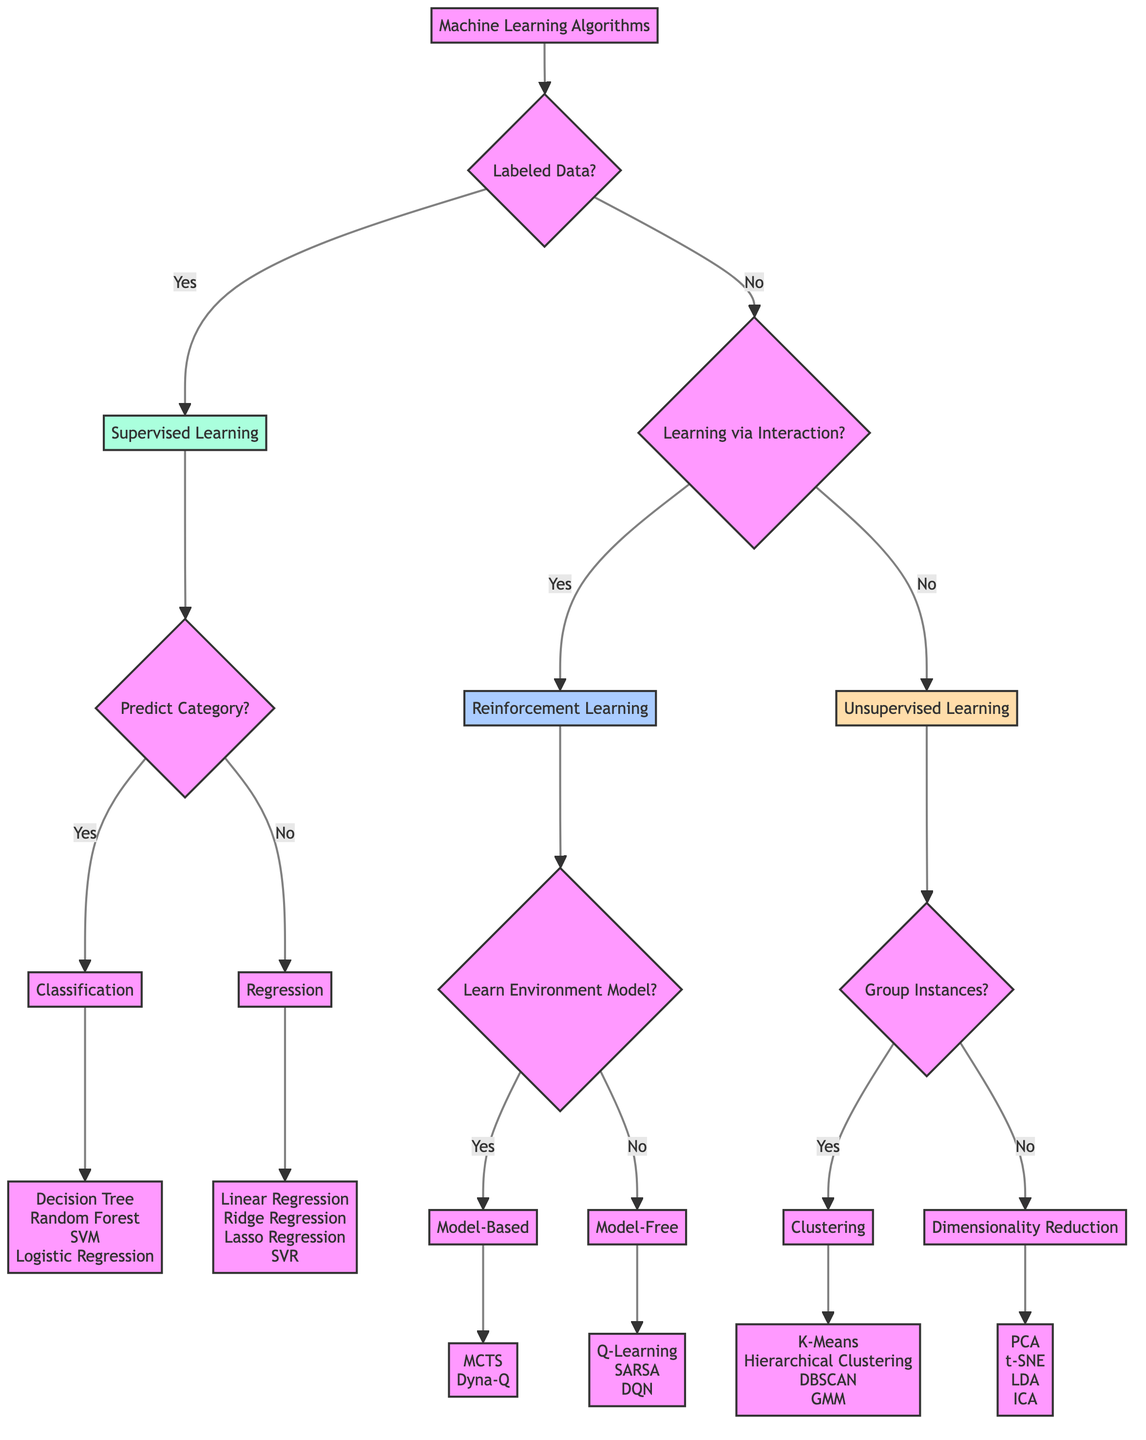What are the main types of learning in the diagram? The diagram outlines three main types of learning: Supervised Learning, Unsupervised Learning, and Reinforcement Learning. These are presented as the top-level branches stemming from the initial question about labeled data.
Answer: Supervised Learning, Unsupervised Learning, Reinforcement Learning How many supervised learning algorithms are categorized under classification? Under the supervised learning branch, the classification category has four examples listed: Decision Tree, Random Forest, Support Vector Machine, and Logistic Regression. Therefore, by counting these examples, we find that there are four algorithms.
Answer: 4 What criteria differentiate reinforcement learning from unsupervised learning? The diagram indicates that reinforcement learning is based on learning via interaction, while unsupervised learning is characterized by the absence of labeled data. This distinction is made at the decision point where the flow diverges between the two learning types.
Answer: Learning via Interaction with Environment How many total children nodes are under the supervised learning category? The supervised learning category has two children branches: classification and regression. Each of these children might further have examples, but the count of direct children nodes is two.
Answer: 2 Which unsupervised learning method is associated with grouping similar instances? In the unsupervised learning section, clustering is defined by the criteria "Grouping Similar Instances." This label directly associates clustering with the concept described, showing it's the method focused on this criterion.
Answer: Clustering What examples are listed under dimensionality reduction? The diagram lists four methods under dimensionality reduction. These examples are Principal Component Analysis, t-Distributed Stochastic Neighbor Embedding, Linear Discriminant Analysis, and Independent Component Analysis. Counting these gives us four specific examples linked to the dimensionality reduction category.
Answer: Principal Component Analysis, t-Distributed Stochastic Neighbor Embedding, Linear Discriminant Analysis, Independent Component Analysis How does one differentiate between model-free and model-based reinforcement learning? In the reinforcement learning branch, the decision node categorizes learning approaches based on whether they involve learning an environment model or not. Model-free learning does not involve this model, while model-based learning does, thus highlighting this key distinguishing factor.
Answer: Model-Free, Model-Based What is the main criterion for supervised learning? The main criterion for supervised learning as indicated in the diagram is the availability of labeled data. This decision node serves as the initial branching point that establishes the path between supervised and unsupervised learning.
Answer: Labeled Data Available 